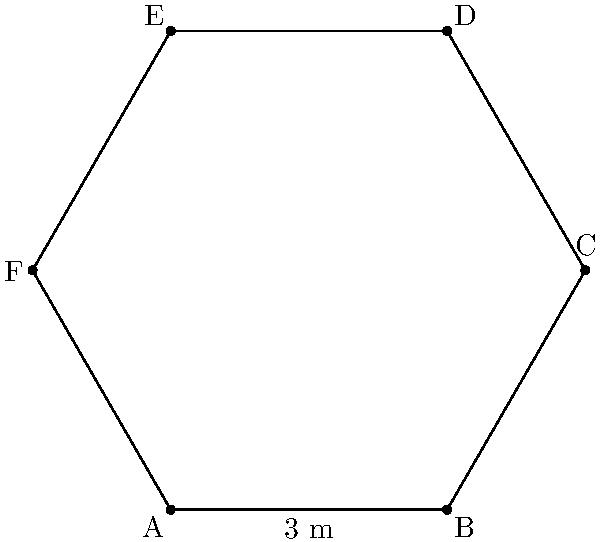A hexagonal nurses' station is being designed for a new hospital ward to optimize workflow and patient monitoring. The station has six equal sides, each measuring 3 meters in length. Calculate the total floor area of this nurses' station to ensure adequate space for equipment and staff movement. To find the area of a regular hexagon, we can use the formula:

$$A = \frac{3\sqrt{3}}{2}s^2$$

Where $s$ is the length of one side.

Step 1: Identify the given information
- The hexagon has 6 equal sides
- Each side length $s = 3$ meters

Step 2: Substitute the side length into the formula
$$A = \frac{3\sqrt{3}}{2}(3^2)$$

Step 3: Simplify the expression
$$A = \frac{3\sqrt{3}}{2}(9)$$
$$A = \frac{27\sqrt{3}}{2}$$

Step 4: Calculate the final result
$$A \approx 23.38 \text{ m}^2$$

Therefore, the total floor area of the hexagonal nurses' station is approximately 23.38 square meters.
Answer: $23.38 \text{ m}^2$ 